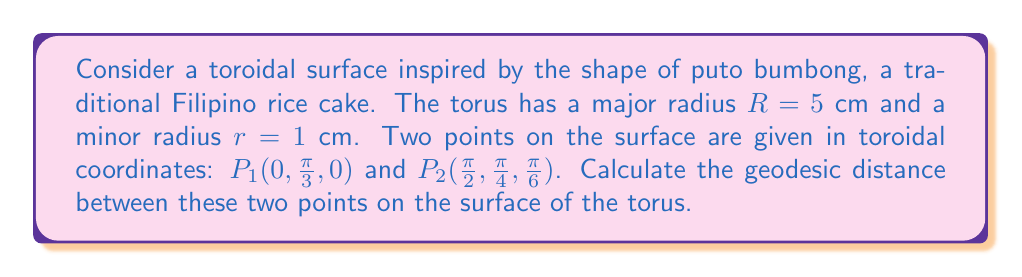Provide a solution to this math problem. To solve this problem, we'll follow these steps:

1) The metric for a torus in toroidal coordinates $(\theta, \phi, \psi)$ is given by:

   $$ds^2 = (R + r\cos\phi)^2 d\theta^2 + r^2d\phi^2 + r^2\sin^2\phi d\psi^2$$

2) For geodesics on a torus, we can use the Clairaut relation:

   $$(R + r\cos\phi)\sin\alpha = \text{constant}$$

   where $\alpha$ is the angle between the geodesic and the lines of longitude.

3) To find the geodesic distance, we need to solve the Euler-Lagrange equations derived from the metric. However, this is a complex differential equation that doesn't have a closed-form solution.

4) For an approximation, we can use the formula for the Euclidean distance in toroidal coordinates:

   $$d^2 = (R + r\cos\phi_1)^2 + (R + r\cos\phi_2)^2 - 2(R + r\cos\phi_1)(R + r\cos\phi_2)\cos(\theta_2 - \theta_1) + r^2(\phi_2 - \phi_1)^2 + r^2(\psi_2 - \psi_1)^2$$

5) Substituting our values:
   $R = 5$, $r = 1$
   $P_1: \theta_1 = 0$, $\phi_1 = \frac{\pi}{3}$, $\psi_1 = 0$
   $P_2: \theta_2 = \frac{\pi}{2}$, $\phi_2 = \frac{\pi}{4}$, $\psi_2 = \frac{\pi}{6}$

6) Calculating:
   $$d^2 = (5 + \cos\frac{\pi}{3})^2 + (5 + \cos\frac{\pi}{4})^2 - 2(5 + \cos\frac{\pi}{3})(5 + \cos\frac{\pi}{4})\cos(\frac{\pi}{2} - 0) + (\frac{\pi}{4} - \frac{\pi}{3})^2 + (\frac{\pi}{6} - 0)^2$$

7) Simplifying:
   $$d^2 = (5.5)^2 + (5.707)^2 - 2(5.5)(5.707)(0) + (-0.262)^2 + (0.524)^2$$
   $$d^2 = 30.25 + 32.57 + 0.069 + 0.275 = 63.164$$

8) Taking the square root:
   $$d \approx 7.95 \text{ cm}$$

Note: This is an approximation of the geodesic distance. The actual geodesic path would be slightly shorter, but would require more complex calculations to determine exactly.
Answer: $7.95 \text{ cm}$ (approximate) 